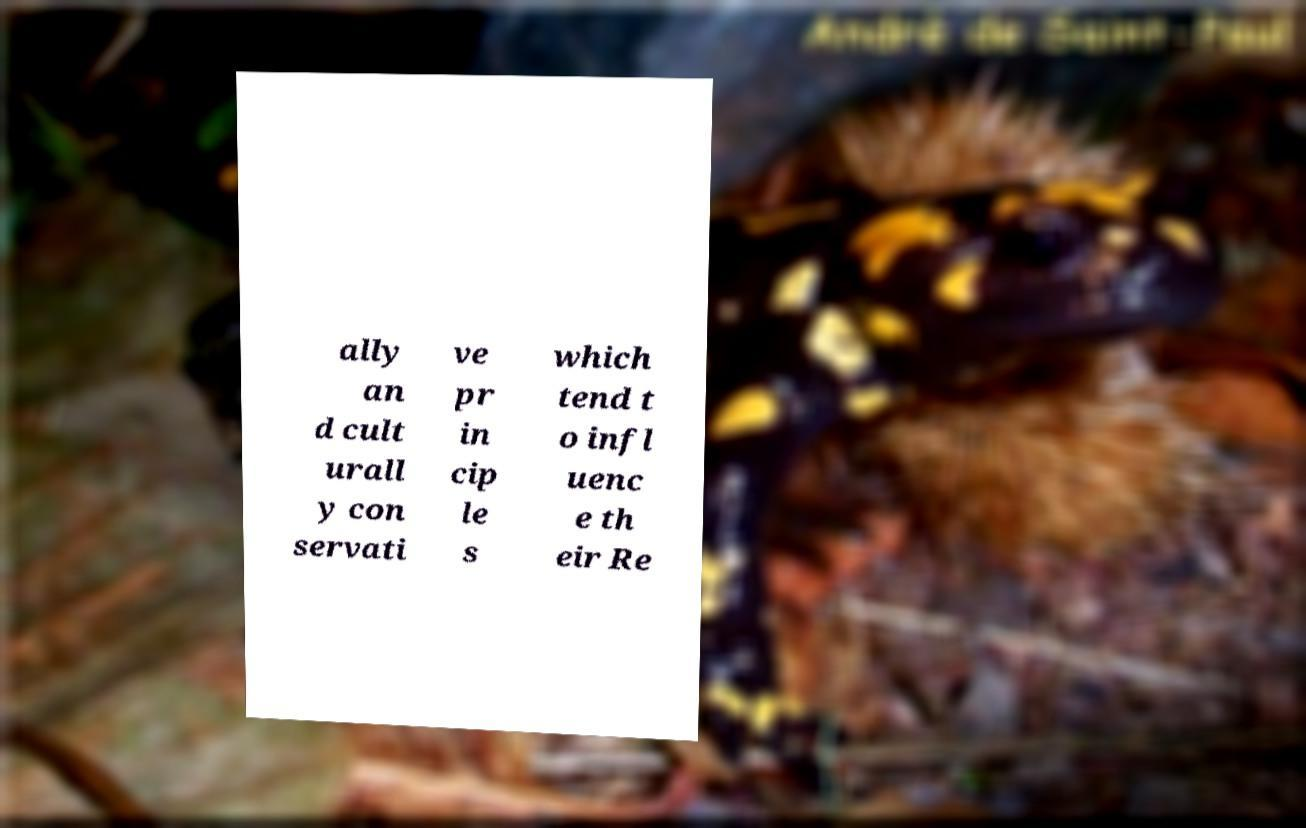Can you read and provide the text displayed in the image?This photo seems to have some interesting text. Can you extract and type it out for me? ally an d cult urall y con servati ve pr in cip le s which tend t o infl uenc e th eir Re 